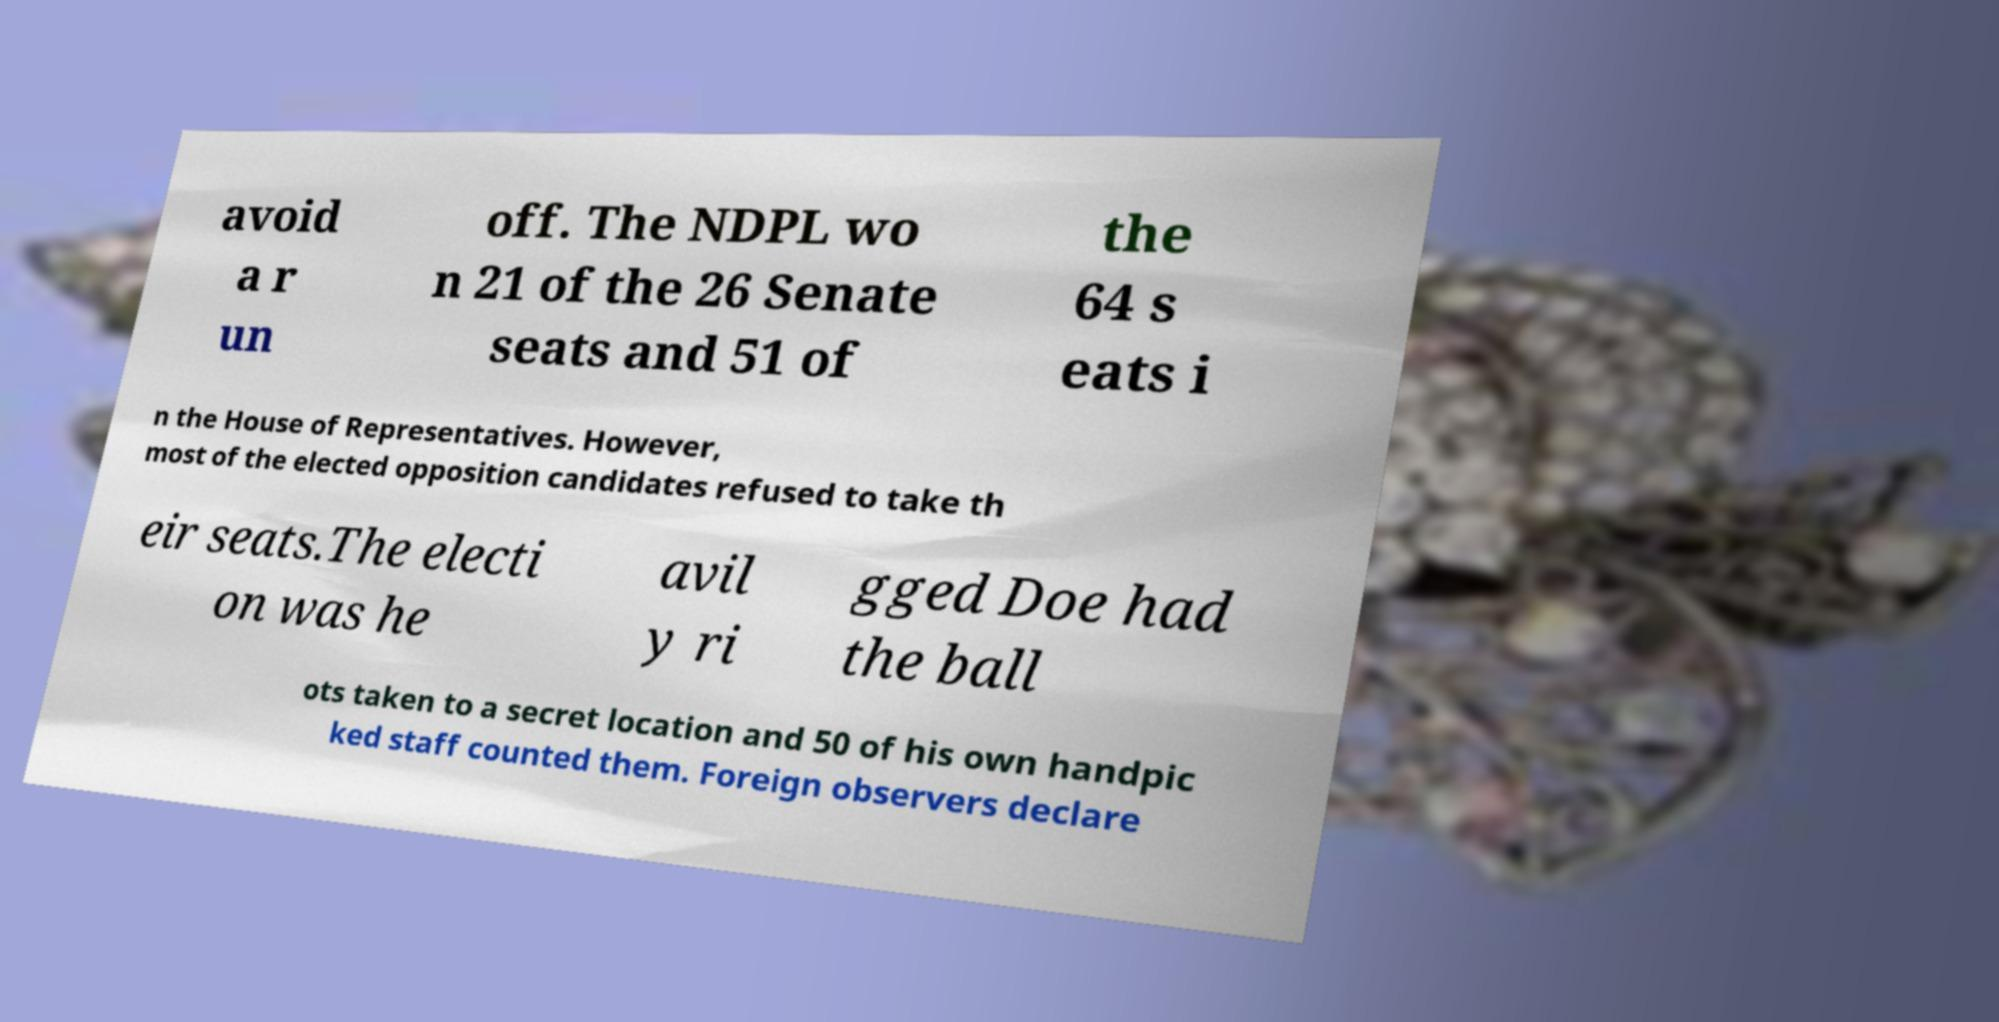Can you accurately transcribe the text from the provided image for me? avoid a r un off. The NDPL wo n 21 of the 26 Senate seats and 51 of the 64 s eats i n the House of Representatives. However, most of the elected opposition candidates refused to take th eir seats.The electi on was he avil y ri gged Doe had the ball ots taken to a secret location and 50 of his own handpic ked staff counted them. Foreign observers declare 